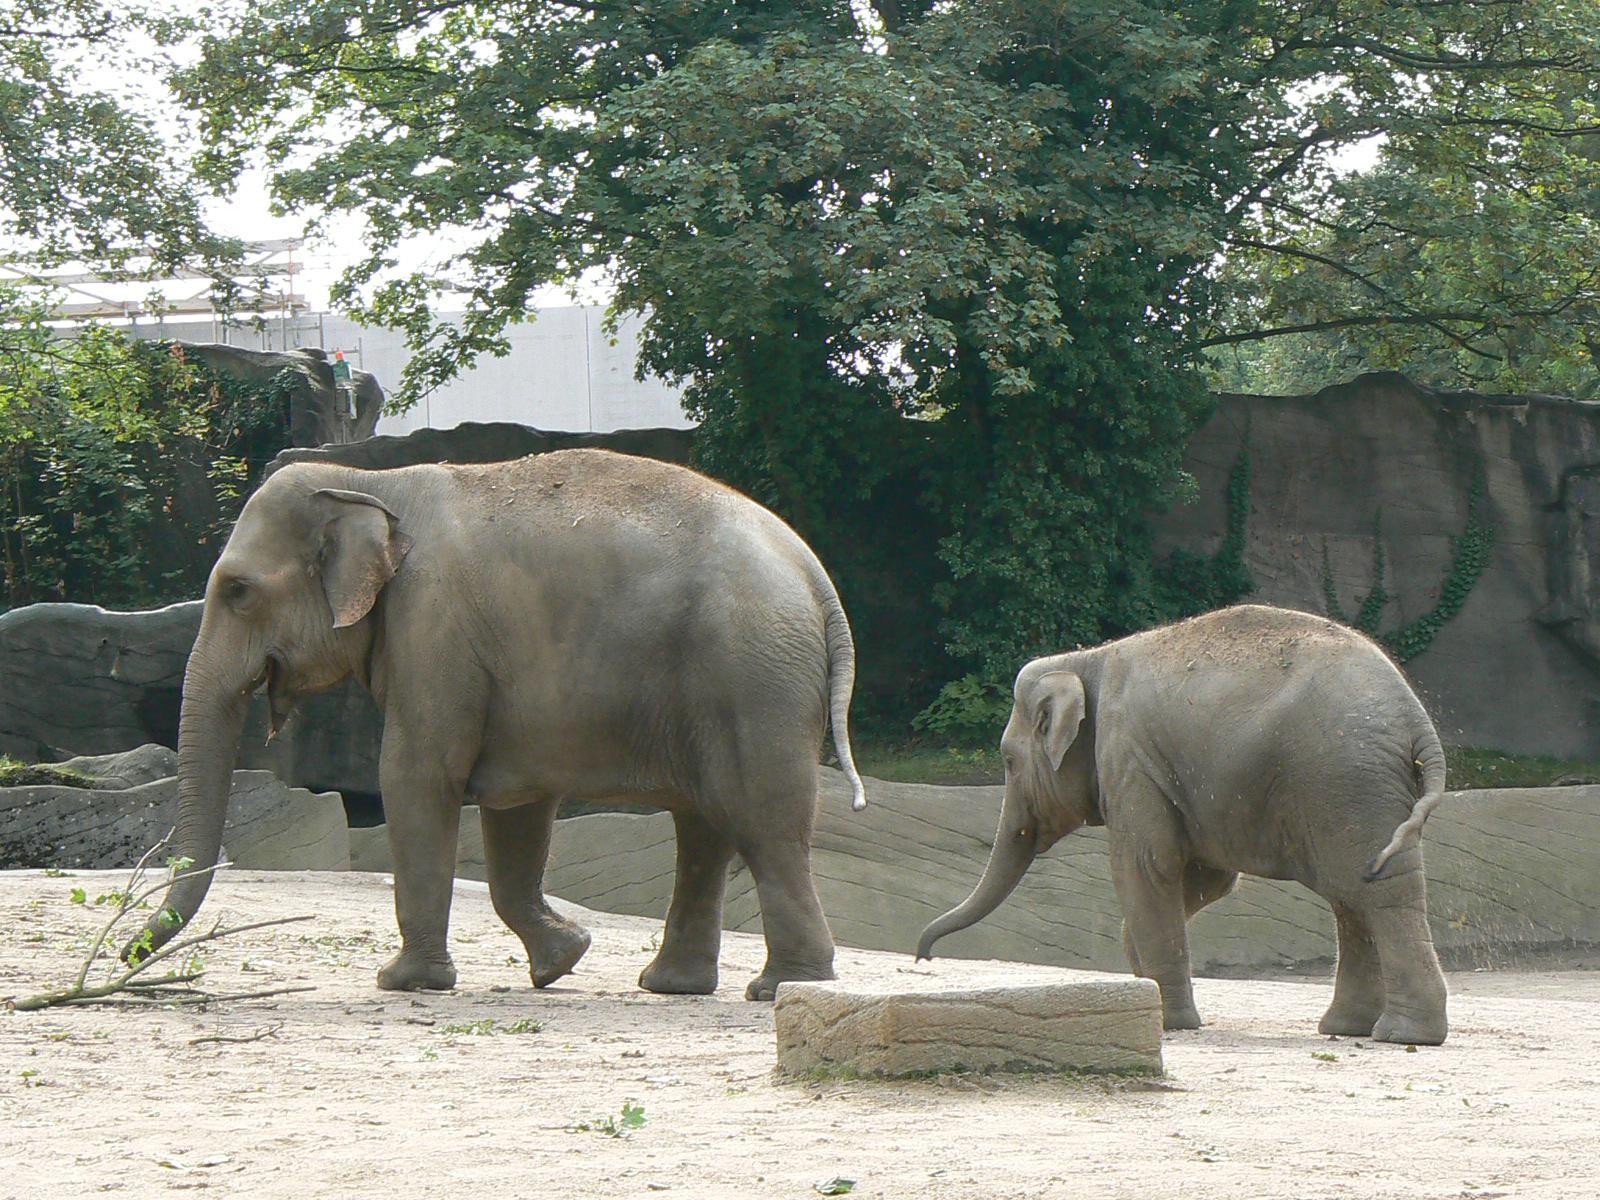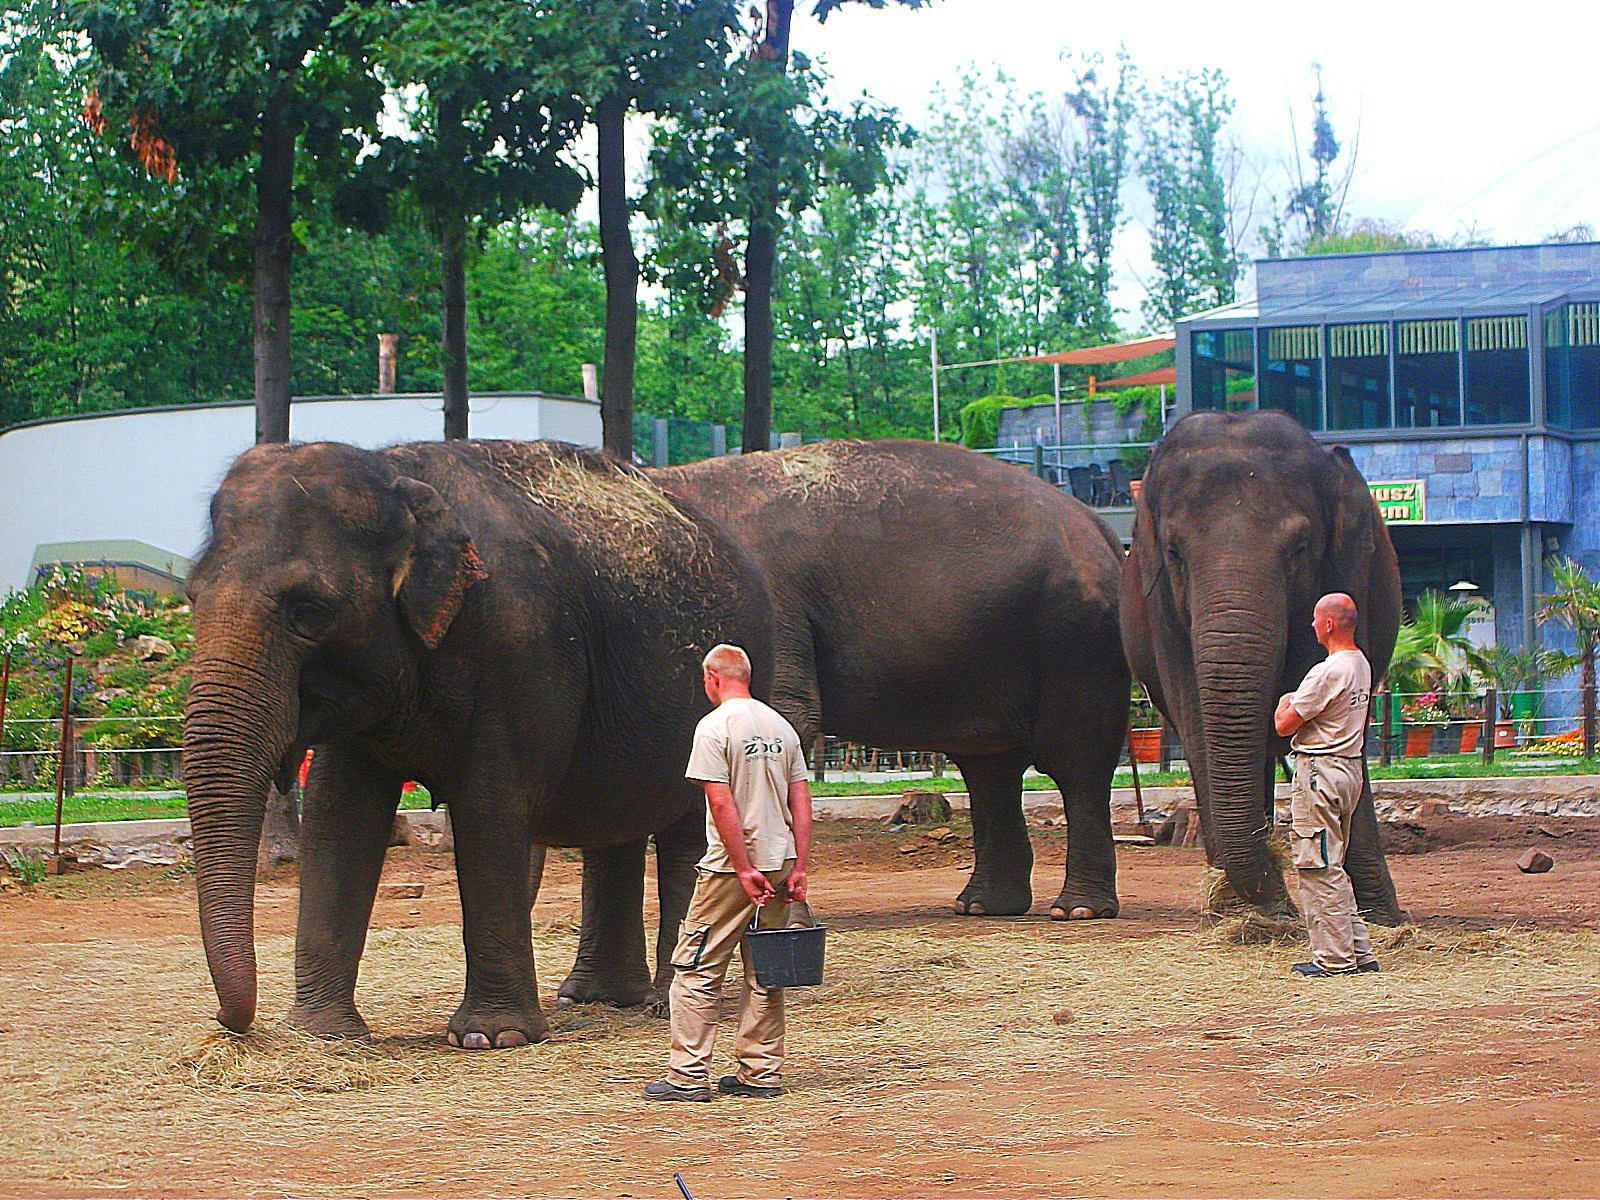The first image is the image on the left, the second image is the image on the right. Analyze the images presented: Is the assertion "An image shows multiple people in a scene containing several elephants." valid? Answer yes or no. Yes. The first image is the image on the left, the second image is the image on the right. Assess this claim about the two images: "There are less than three elephants in at least one of the images.". Correct or not? Answer yes or no. Yes. 